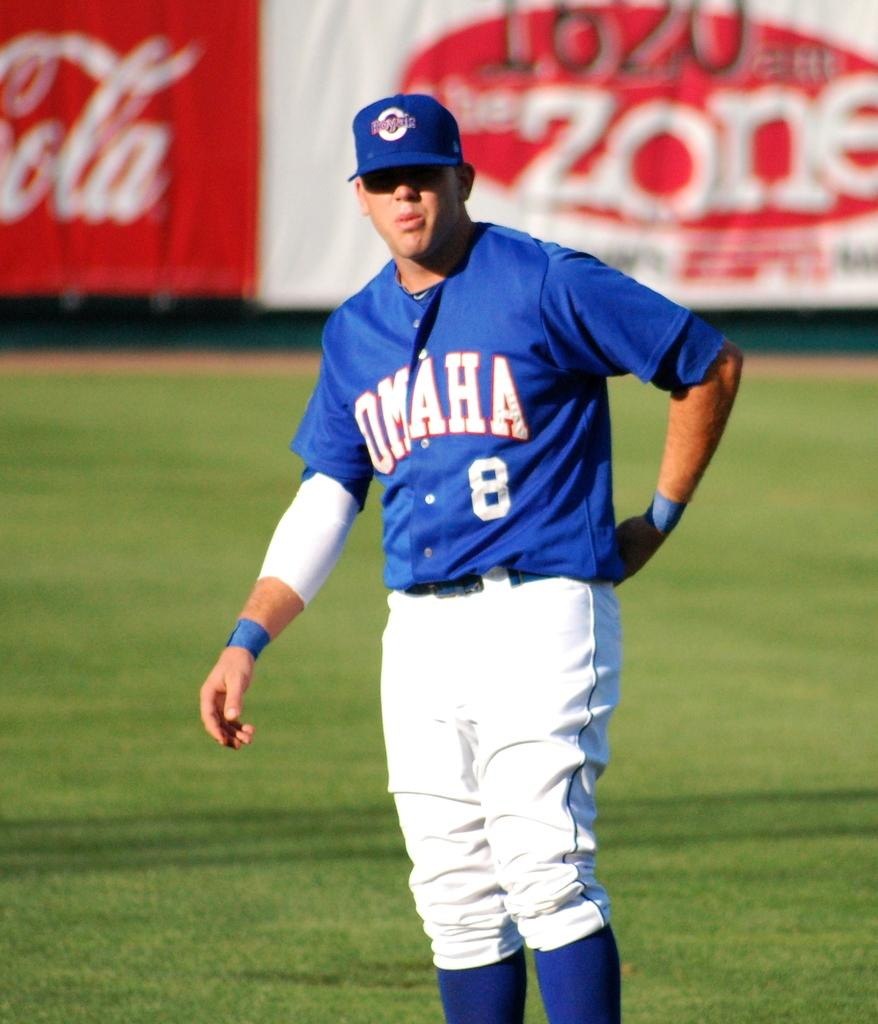Provide a one-sentence caption for the provided image. A Baseball player on the field playing for Omaha wearing the number 8 on his blue shirt wearing white pants. 